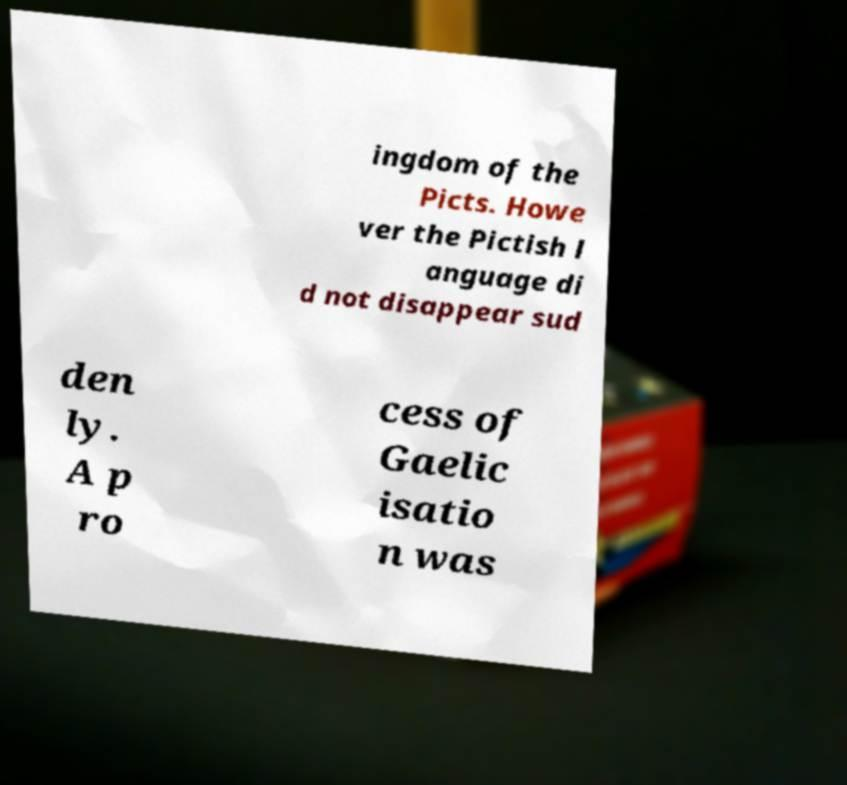Please identify and transcribe the text found in this image. ingdom of the Picts. Howe ver the Pictish l anguage di d not disappear sud den ly. A p ro cess of Gaelic isatio n was 